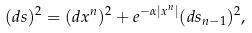Convert formula to latex. <formula><loc_0><loc_0><loc_500><loc_500>( d s ) ^ { 2 } = ( d x ^ { n } ) ^ { 2 } + e ^ { - \alpha | x ^ { n } | } ( d s _ { n - 1 } ) ^ { 2 } ,</formula> 